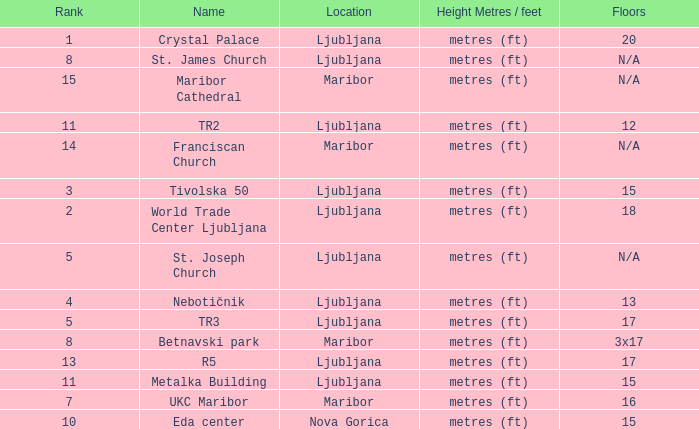Which Height Metres / feet has a Rank of 8, and Floors of 3x17? Metres (ft). Parse the table in full. {'header': ['Rank', 'Name', 'Location', 'Height Metres / feet', 'Floors'], 'rows': [['1', 'Crystal Palace', 'Ljubljana', 'metres (ft)', '20'], ['8', 'St. James Church', 'Ljubljana', 'metres (ft)', 'N/A'], ['15', 'Maribor Cathedral', 'Maribor', 'metres (ft)', 'N/A'], ['11', 'TR2', 'Ljubljana', 'metres (ft)', '12'], ['14', 'Franciscan Church', 'Maribor', 'metres (ft)', 'N/A'], ['3', 'Tivolska 50', 'Ljubljana', 'metres (ft)', '15'], ['2', 'World Trade Center Ljubljana', 'Ljubljana', 'metres (ft)', '18'], ['5', 'St. Joseph Church', 'Ljubljana', 'metres (ft)', 'N/A'], ['4', 'Nebotičnik', 'Ljubljana', 'metres (ft)', '13'], ['5', 'TR3', 'Ljubljana', 'metres (ft)', '17'], ['8', 'Betnavski park', 'Maribor', 'metres (ft)', '3x17'], ['13', 'R5', 'Ljubljana', 'metres (ft)', '17'], ['11', 'Metalka Building', 'Ljubljana', 'metres (ft)', '15'], ['7', 'UKC Maribor', 'Maribor', 'metres (ft)', '16'], ['10', 'Eda center', 'Nova Gorica', 'metres (ft)', '15']]} 